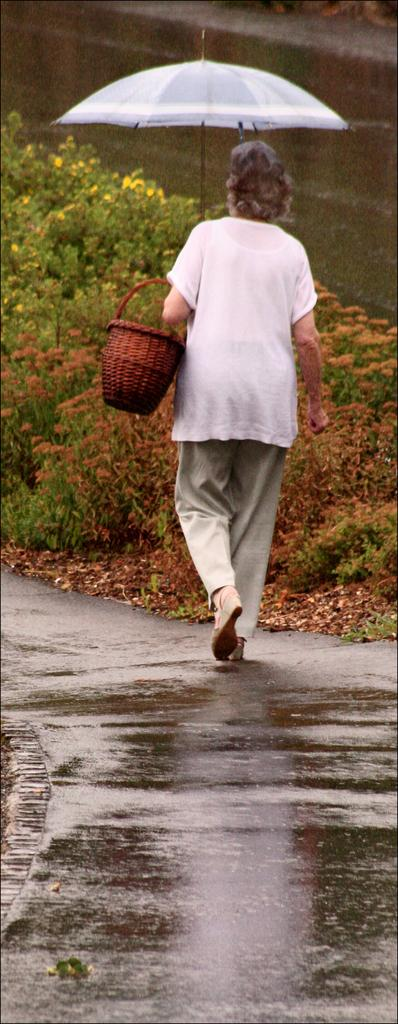Who is present in the image? There is a woman in the image. What is the woman holding in the image? The woman is holding a basket and an umbrella. What is the woman doing in the image? The woman is walking on a road. What can be seen in the background of the image? There are plants in the background of the image. What type of bulb is used to light up the road in the image? There is no mention of any bulbs or lighting in the image; it only shows a woman walking on a road with plants in the background. 